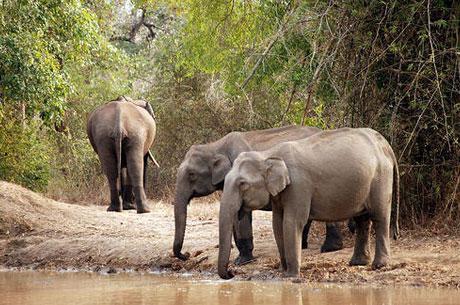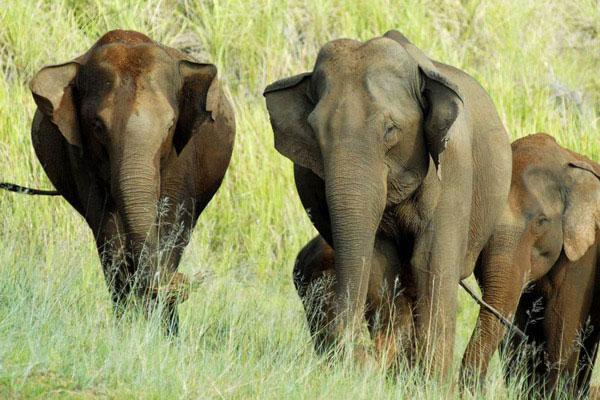The first image is the image on the left, the second image is the image on the right. Analyze the images presented: Is the assertion "Some of the animals are near the water." valid? Answer yes or no. Yes. 